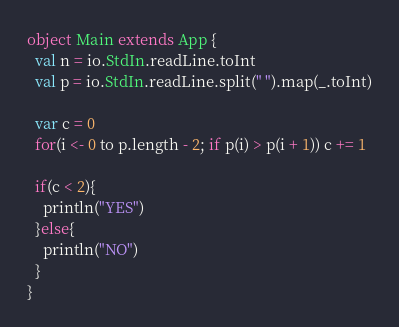<code> <loc_0><loc_0><loc_500><loc_500><_Scala_>object Main extends App {
  val n = io.StdIn.readLine.toInt
  val p = io.StdIn.readLine.split(" ").map(_.toInt)

  var c = 0
  for(i <- 0 to p.length - 2; if p(i) > p(i + 1)) c += 1

  if(c < 2){
    println("YES")
  }else{
    println("NO")
  }
}
</code> 